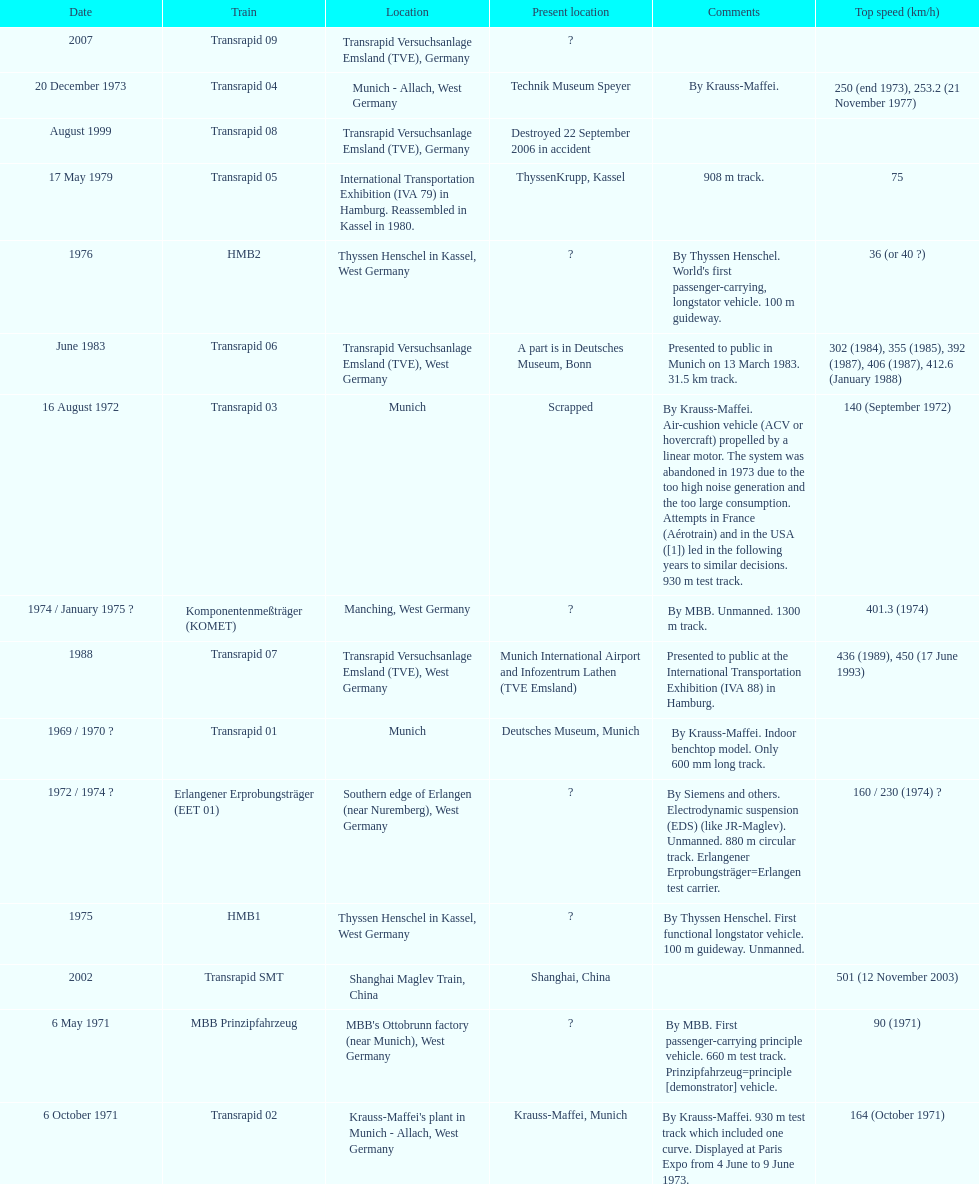Tell me the number of versions that are scrapped. 1. 